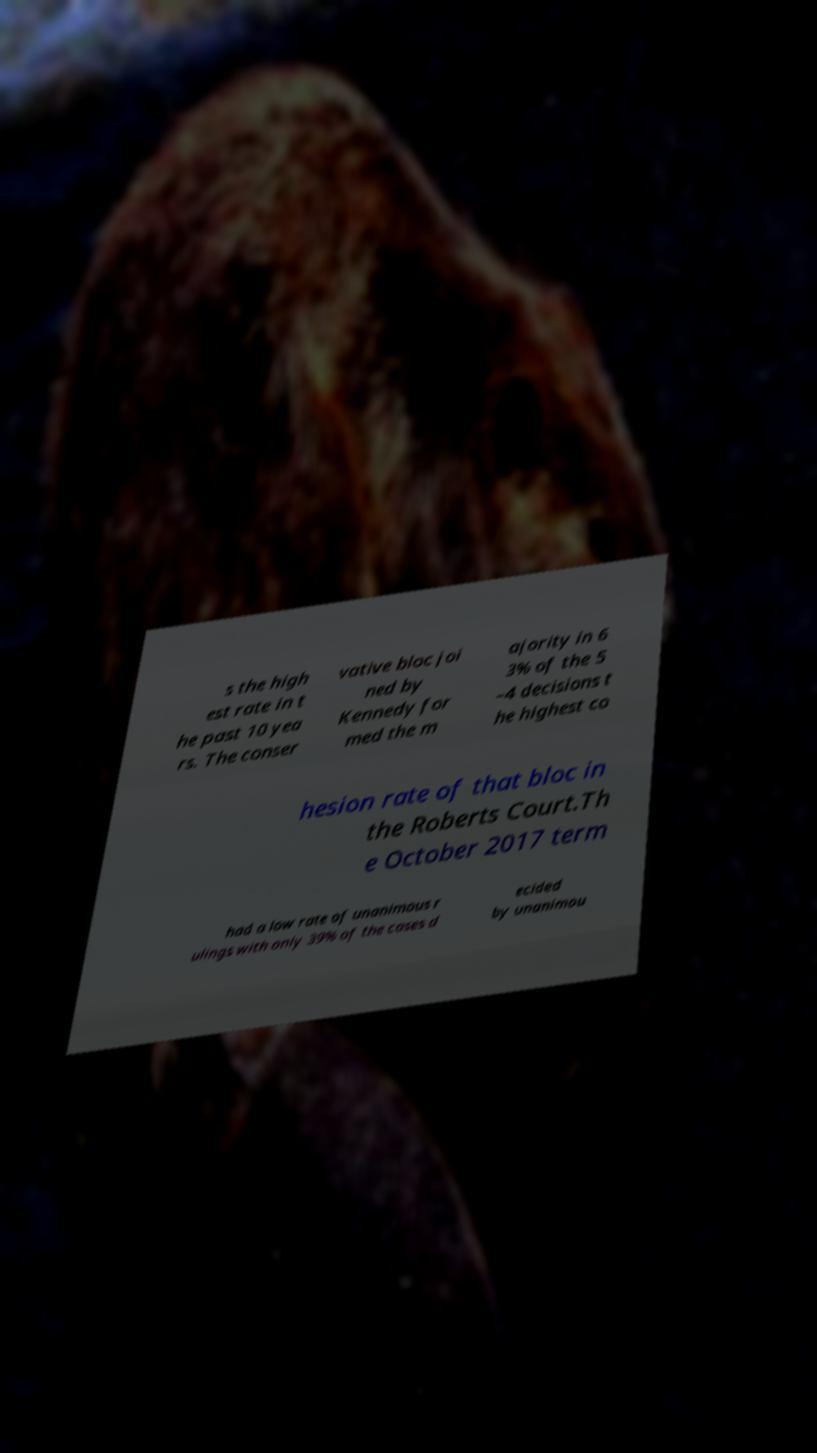Could you assist in decoding the text presented in this image and type it out clearly? s the high est rate in t he past 10 yea rs. The conser vative bloc joi ned by Kennedy for med the m ajority in 6 3% of the 5 –4 decisions t he highest co hesion rate of that bloc in the Roberts Court.Th e October 2017 term had a low rate of unanimous r ulings with only 39% of the cases d ecided by unanimou 